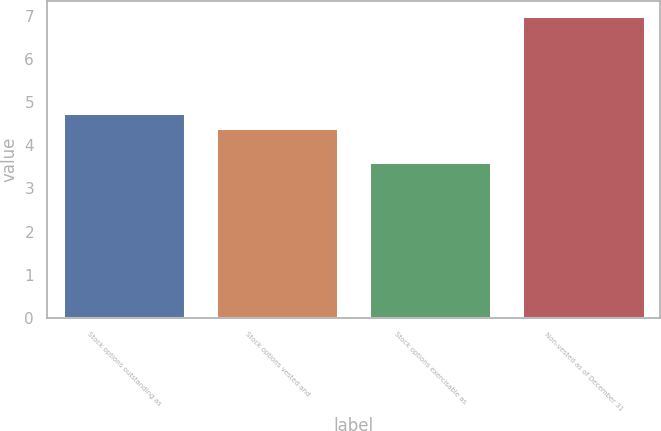Convert chart to OTSL. <chart><loc_0><loc_0><loc_500><loc_500><bar_chart><fcel>Stock options outstanding as<fcel>Stock options vested and<fcel>Stock options exercisable as<fcel>Non-vested as of December 31<nl><fcel>4.74<fcel>4.4<fcel>3.6<fcel>7<nl></chart> 